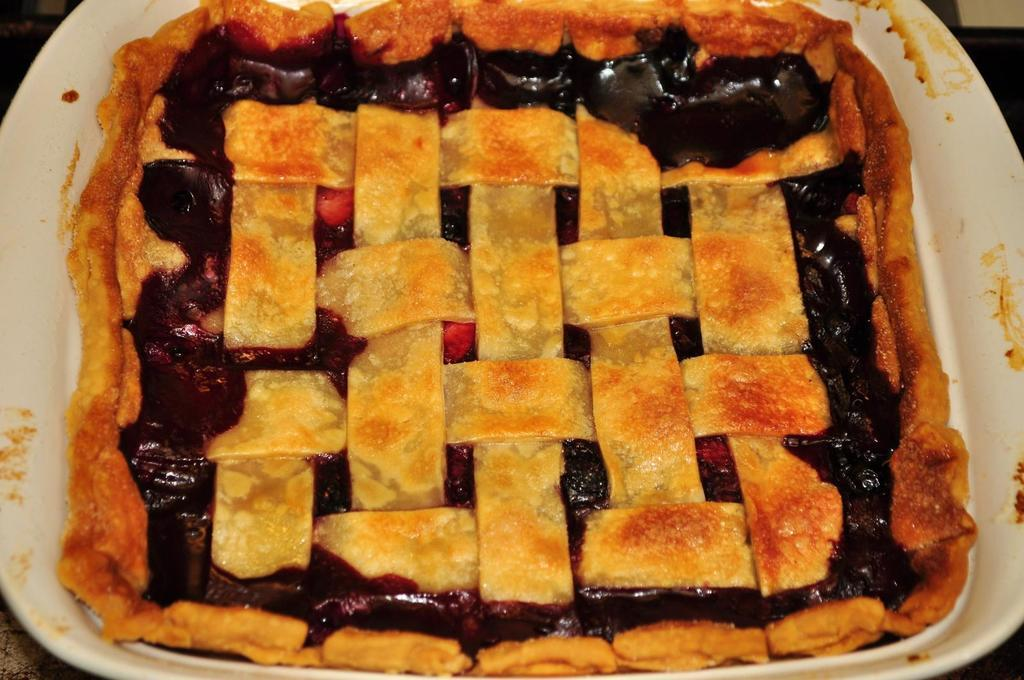What is present on the plate in the image? There is food in a plate in the image. What thoughts are the children having about the food in the image? There are no children present in the image, and therefore no thoughts about the food can be determined. 